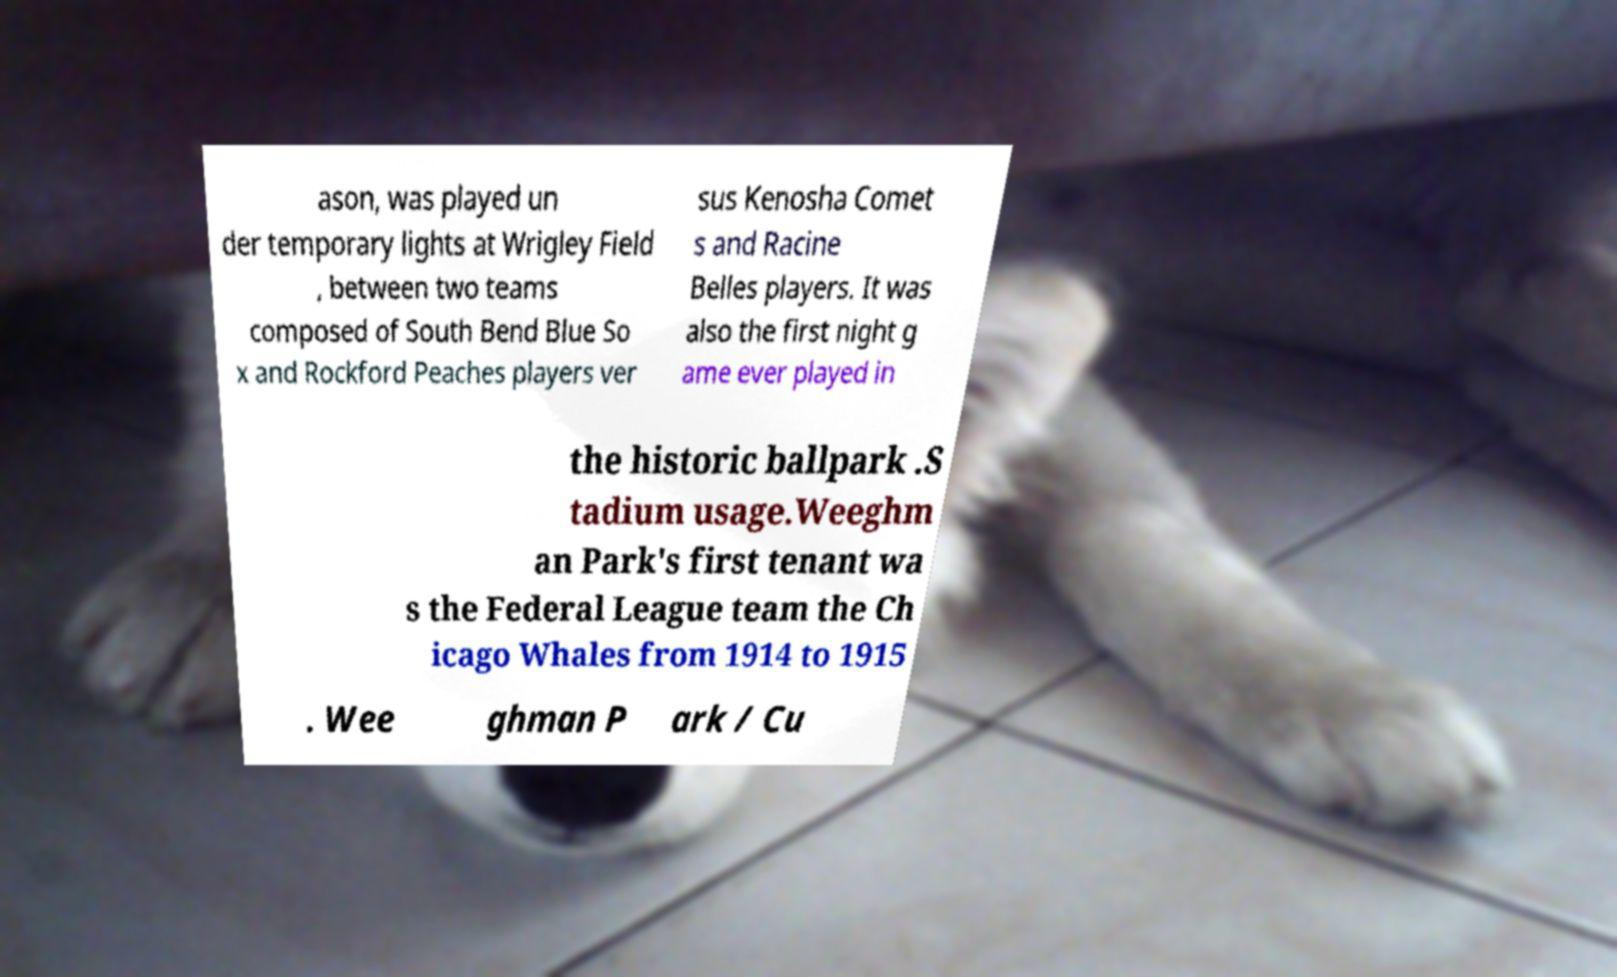There's text embedded in this image that I need extracted. Can you transcribe it verbatim? ason, was played un der temporary lights at Wrigley Field , between two teams composed of South Bend Blue So x and Rockford Peaches players ver sus Kenosha Comet s and Racine Belles players. It was also the first night g ame ever played in the historic ballpark .S tadium usage.Weeghm an Park's first tenant wa s the Federal League team the Ch icago Whales from 1914 to 1915 . Wee ghman P ark / Cu 